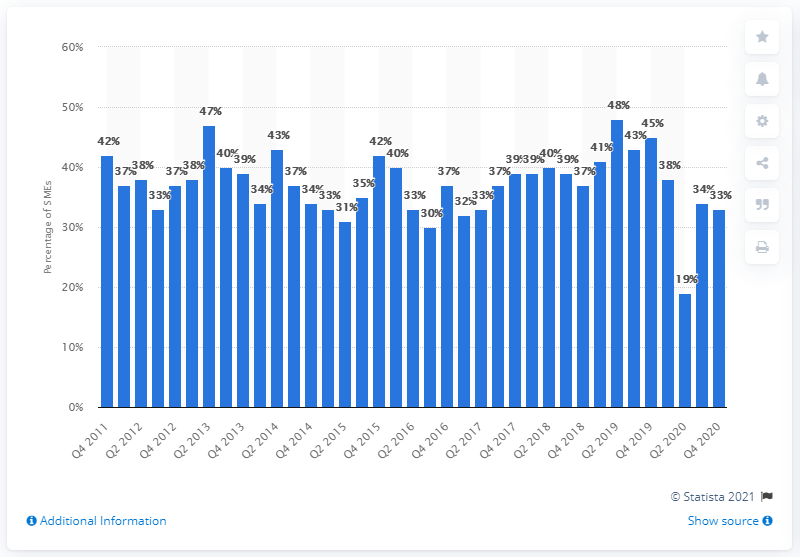Identify some key points in this picture. According to the survey conducted on construction sector SMEs, 47% of them stated that they plan to grow in the upcoming 12 months. 